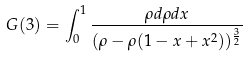Convert formula to latex. <formula><loc_0><loc_0><loc_500><loc_500>G ( 3 ) = \int _ { 0 } ^ { 1 } \frac { \rho d \rho d x } { ( \rho - \rho ( 1 - x + x ^ { 2 } ) ) ^ { \frac { 3 } { 2 } } }</formula> 